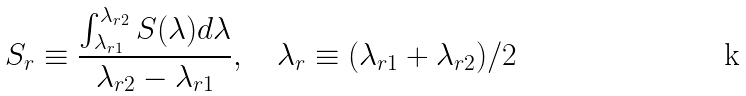<formula> <loc_0><loc_0><loc_500><loc_500>S _ { r } \equiv \frac { \int _ { \lambda _ { r 1 } } ^ { \lambda _ { r 2 } } S ( \lambda ) d \lambda } { \lambda _ { r 2 } - \lambda _ { r 1 } } , \quad \lambda _ { r } \equiv ( \lambda _ { r 1 } + \lambda _ { r 2 } ) / 2</formula> 